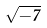Convert formula to latex. <formula><loc_0><loc_0><loc_500><loc_500>\sqrt { - 7 }</formula> 